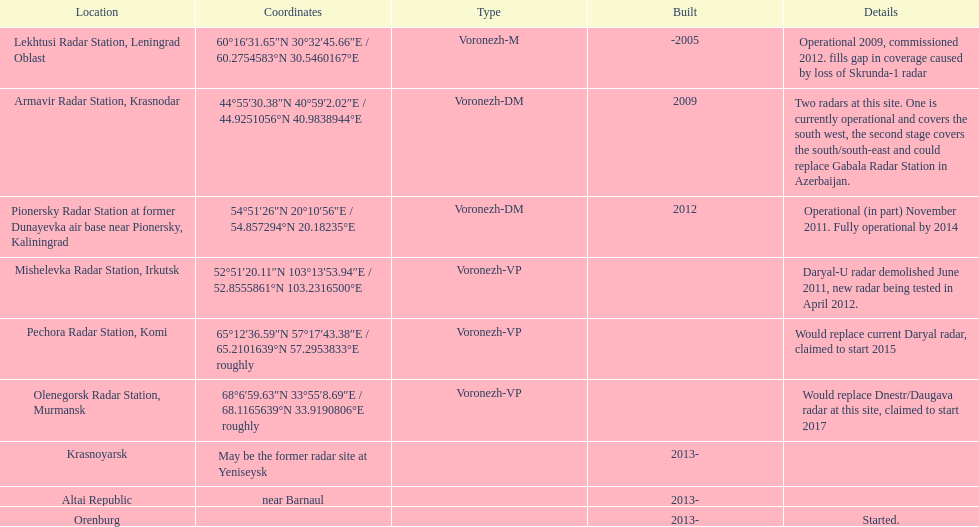What was the time span required for the pionersky radar station to move from partially working to fully working? 3 years. 